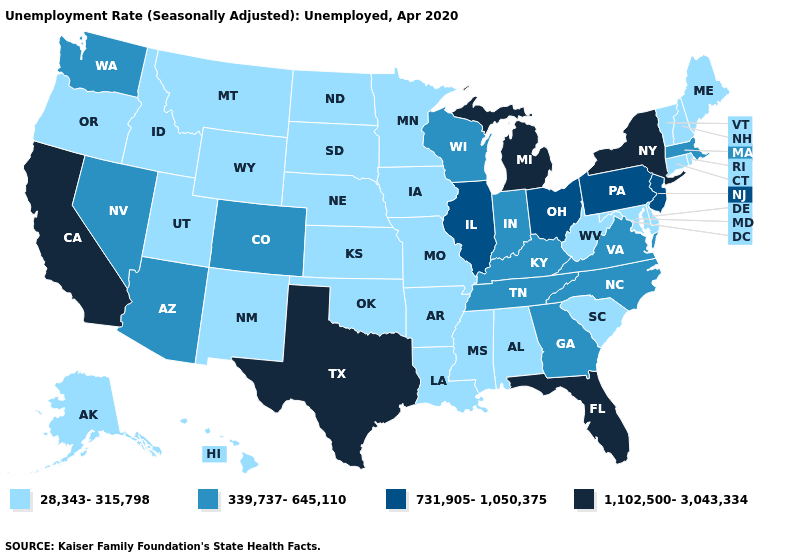Name the states that have a value in the range 731,905-1,050,375?
Concise answer only. Illinois, New Jersey, Ohio, Pennsylvania. Name the states that have a value in the range 28,343-315,798?
Give a very brief answer. Alabama, Alaska, Arkansas, Connecticut, Delaware, Hawaii, Idaho, Iowa, Kansas, Louisiana, Maine, Maryland, Minnesota, Mississippi, Missouri, Montana, Nebraska, New Hampshire, New Mexico, North Dakota, Oklahoma, Oregon, Rhode Island, South Carolina, South Dakota, Utah, Vermont, West Virginia, Wyoming. Is the legend a continuous bar?
Short answer required. No. Among the states that border Pennsylvania , does New York have the lowest value?
Be succinct. No. Name the states that have a value in the range 339,737-645,110?
Concise answer only. Arizona, Colorado, Georgia, Indiana, Kentucky, Massachusetts, Nevada, North Carolina, Tennessee, Virginia, Washington, Wisconsin. Which states have the highest value in the USA?
Be succinct. California, Florida, Michigan, New York, Texas. Name the states that have a value in the range 1,102,500-3,043,334?
Concise answer only. California, Florida, Michigan, New York, Texas. What is the value of Montana?
Keep it brief. 28,343-315,798. Name the states that have a value in the range 731,905-1,050,375?
Keep it brief. Illinois, New Jersey, Ohio, Pennsylvania. What is the value of Michigan?
Write a very short answer. 1,102,500-3,043,334. What is the highest value in the West ?
Short answer required. 1,102,500-3,043,334. Does Pennsylvania have the lowest value in the USA?
Be succinct. No. Among the states that border Nebraska , which have the highest value?
Concise answer only. Colorado. Which states hav the highest value in the Northeast?
Answer briefly. New York. Name the states that have a value in the range 339,737-645,110?
Quick response, please. Arizona, Colorado, Georgia, Indiana, Kentucky, Massachusetts, Nevada, North Carolina, Tennessee, Virginia, Washington, Wisconsin. 